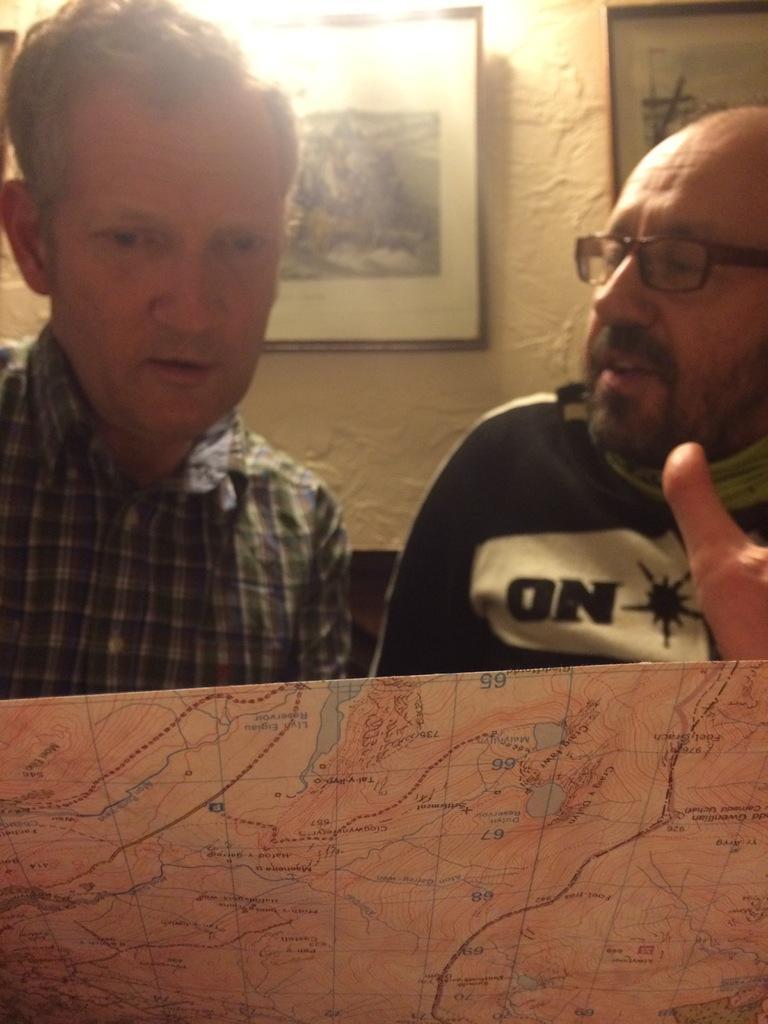Describe this image in one or two sentences. In this image I can see two persons, the person at right is wearing black color shirt and the person at left is wearing gray and white color dress. Background I can see few frames attached to the wall and the wall is in cream color. 